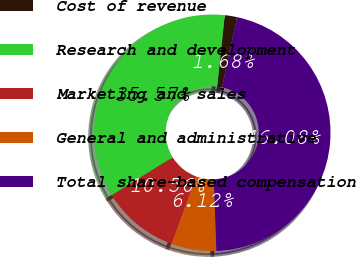Convert chart. <chart><loc_0><loc_0><loc_500><loc_500><pie_chart><fcel>Cost of revenue<fcel>Research and development<fcel>Marketing and sales<fcel>General and administrative<fcel>Total share-based compensation<nl><fcel>1.68%<fcel>35.57%<fcel>10.56%<fcel>6.12%<fcel>46.08%<nl></chart> 